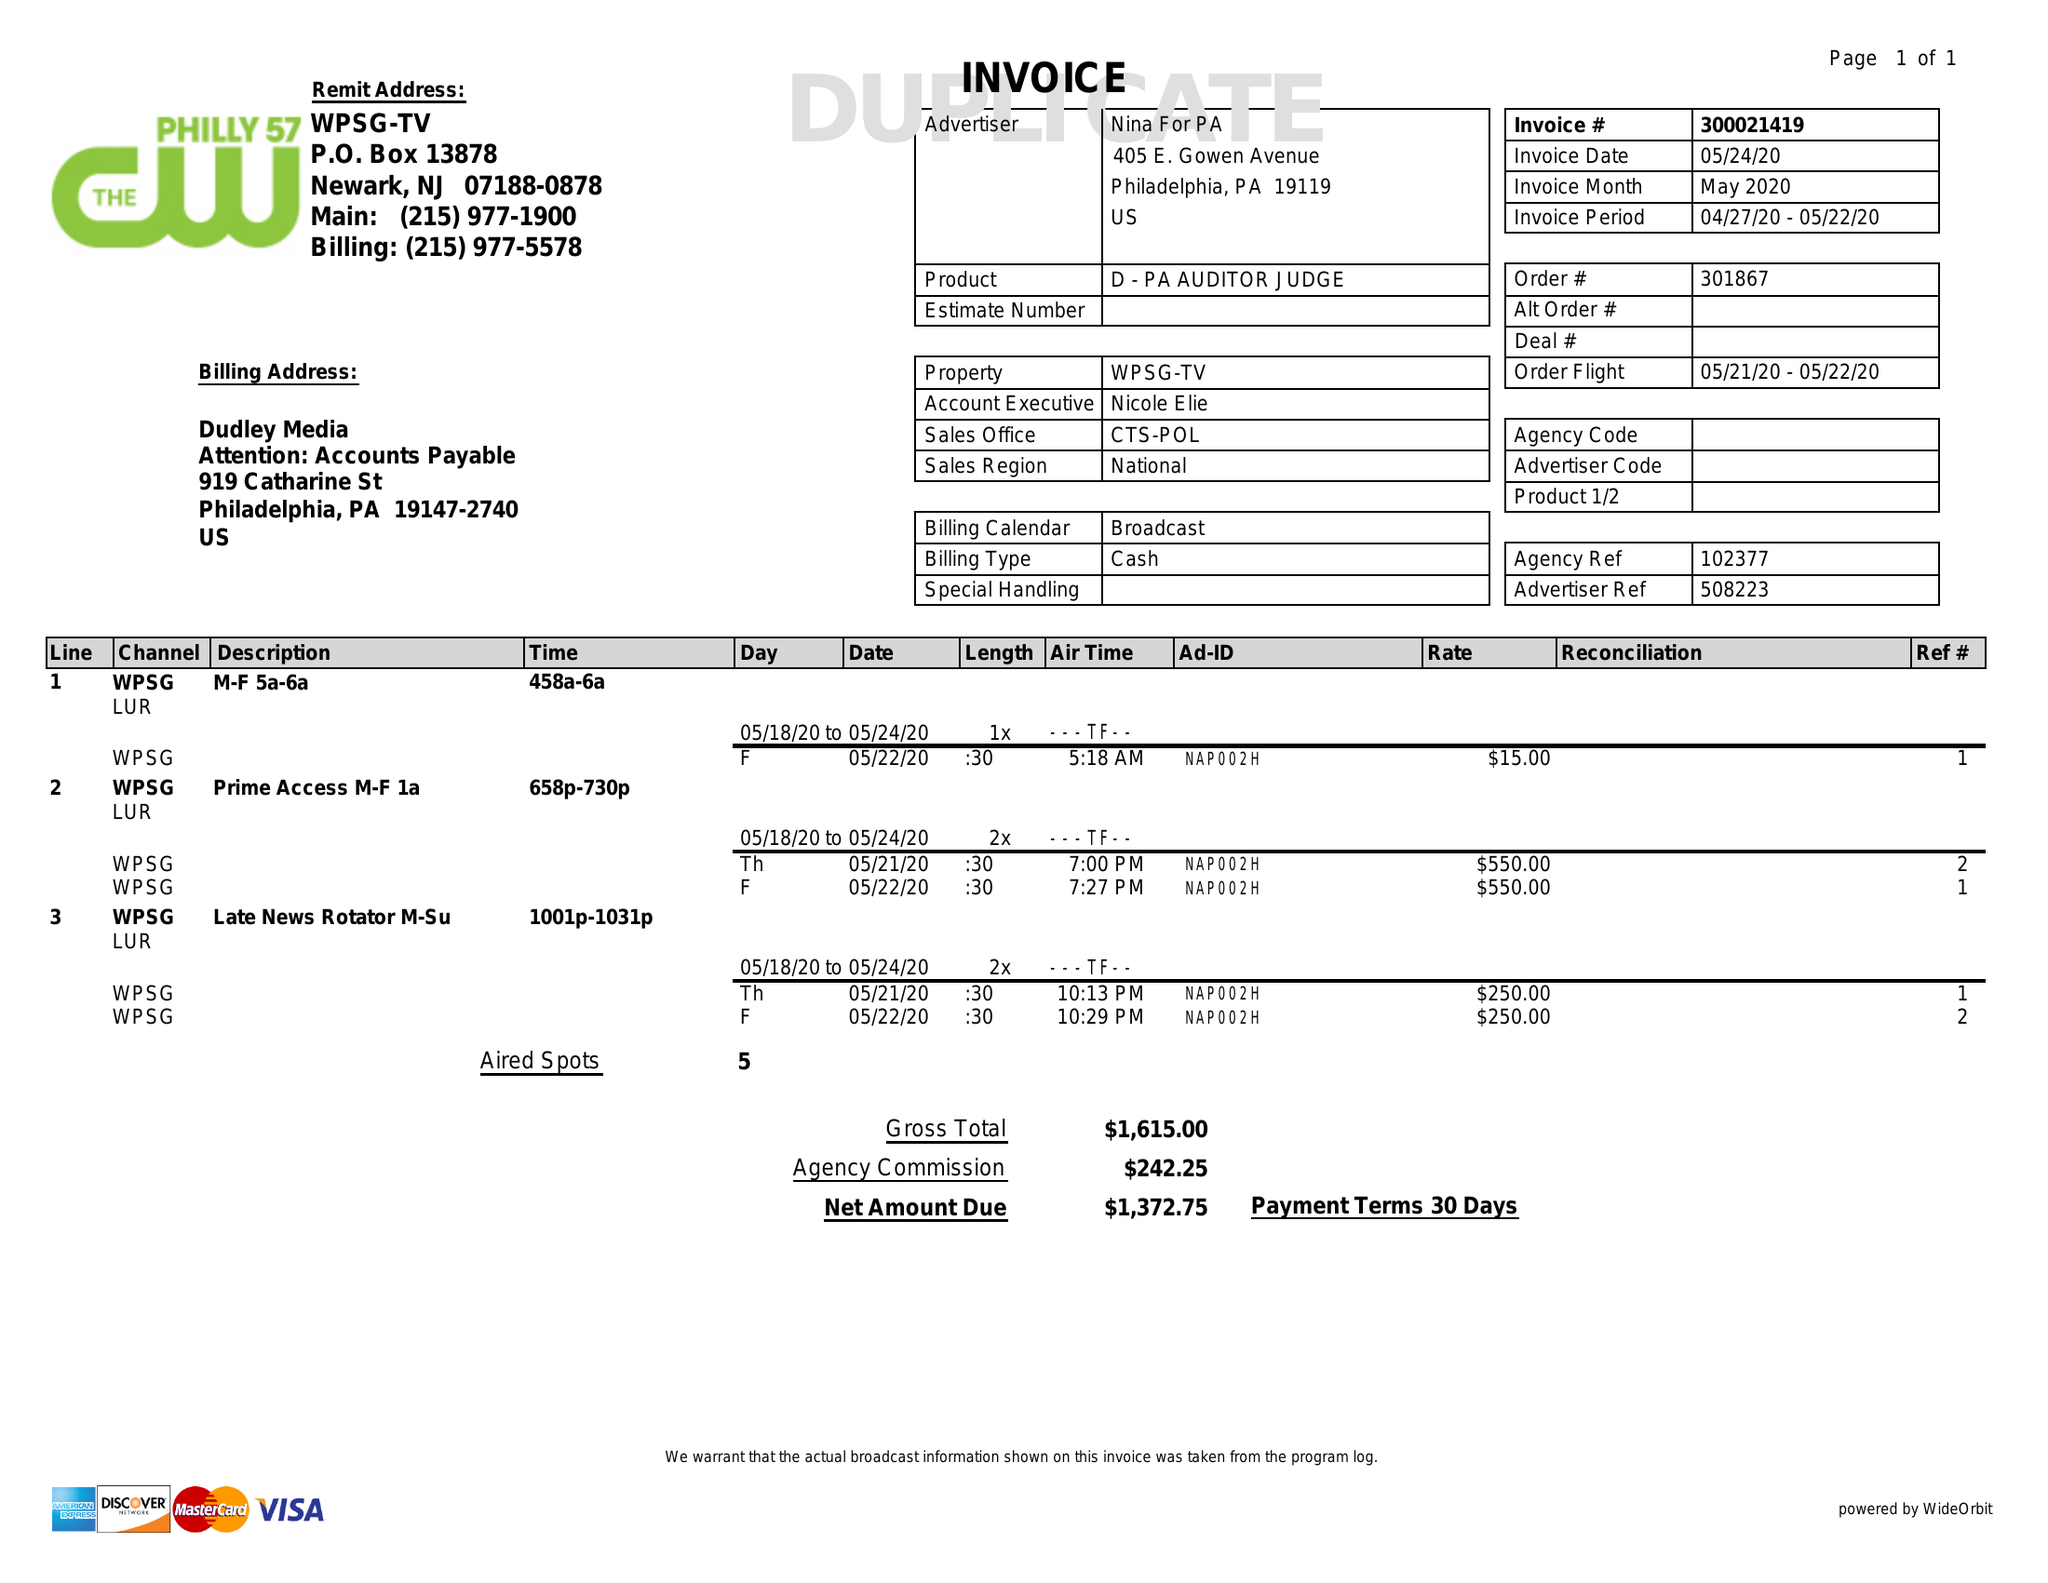What is the value for the advertiser?
Answer the question using a single word or phrase. NINA FOR PA 